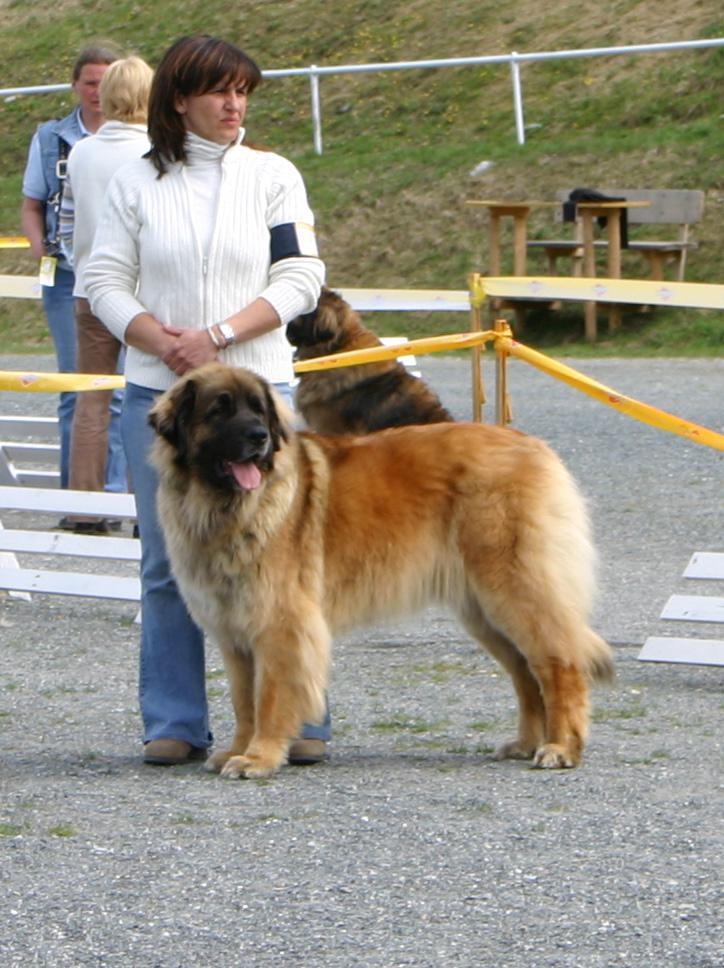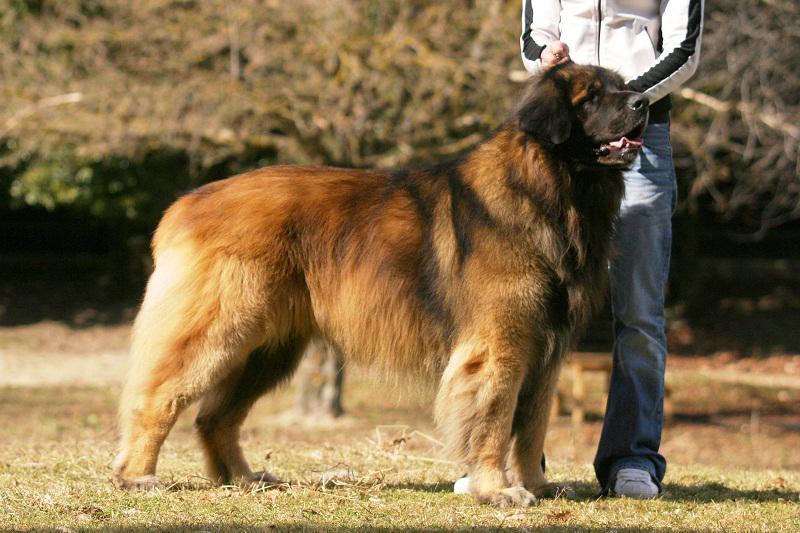The first image is the image on the left, the second image is the image on the right. Evaluate the accuracy of this statement regarding the images: "A little girl is holding a  large dog in the rightmost image.". Is it true? Answer yes or no. No. The first image is the image on the left, the second image is the image on the right. Assess this claim about the two images: "There is one dog lying on the ground in the image on the right.". Correct or not? Answer yes or no. No. 